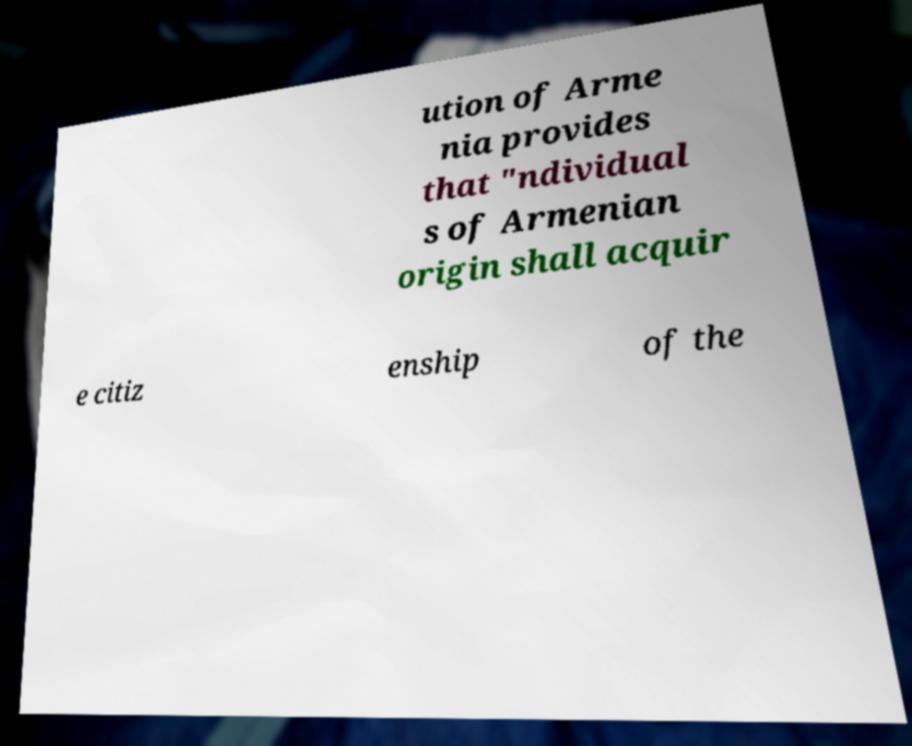Please identify and transcribe the text found in this image. ution of Arme nia provides that "ndividual s of Armenian origin shall acquir e citiz enship of the 